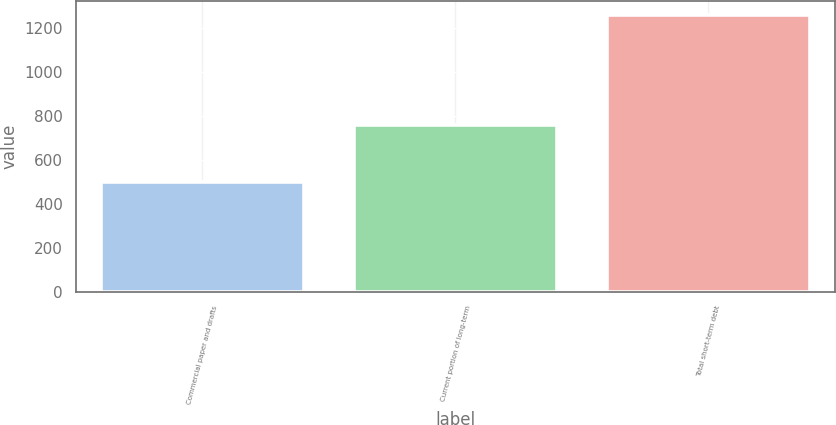<chart> <loc_0><loc_0><loc_500><loc_500><bar_chart><fcel>Commercial paper and drafts<fcel>Current portion of long-term<fcel>Total short-term debt<nl><fcel>500<fcel>761<fcel>1261<nl></chart> 